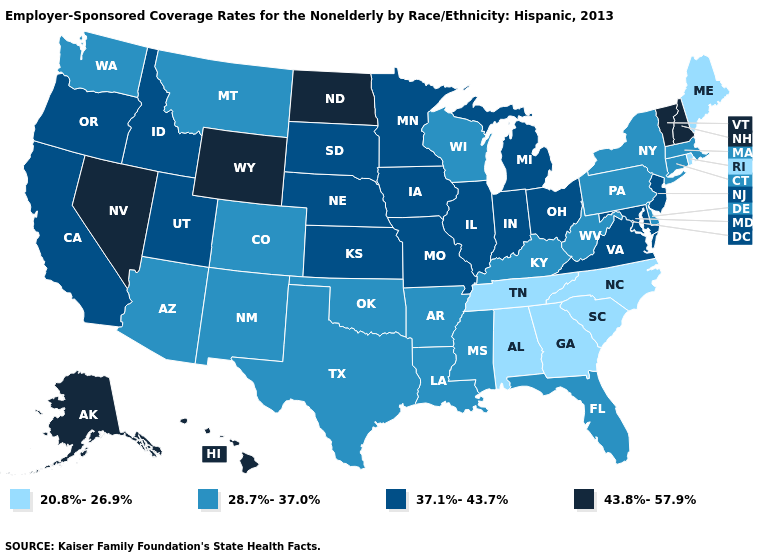What is the lowest value in states that border Mississippi?
Be succinct. 20.8%-26.9%. Which states hav the highest value in the South?
Quick response, please. Maryland, Virginia. What is the value of Alaska?
Answer briefly. 43.8%-57.9%. Does New York have a lower value than Montana?
Quick response, please. No. What is the value of Maryland?
Give a very brief answer. 37.1%-43.7%. What is the value of Texas?
Short answer required. 28.7%-37.0%. What is the highest value in the USA?
Answer briefly. 43.8%-57.9%. What is the value of Ohio?
Concise answer only. 37.1%-43.7%. Does Nevada have the highest value in the USA?
Short answer required. Yes. Among the states that border South Carolina , which have the lowest value?
Answer briefly. Georgia, North Carolina. What is the lowest value in the USA?
Keep it brief. 20.8%-26.9%. How many symbols are there in the legend?
Short answer required. 4. Which states have the highest value in the USA?
Answer briefly. Alaska, Hawaii, Nevada, New Hampshire, North Dakota, Vermont, Wyoming. Among the states that border Oklahoma , which have the lowest value?
Concise answer only. Arkansas, Colorado, New Mexico, Texas. Name the states that have a value in the range 37.1%-43.7%?
Concise answer only. California, Idaho, Illinois, Indiana, Iowa, Kansas, Maryland, Michigan, Minnesota, Missouri, Nebraska, New Jersey, Ohio, Oregon, South Dakota, Utah, Virginia. 